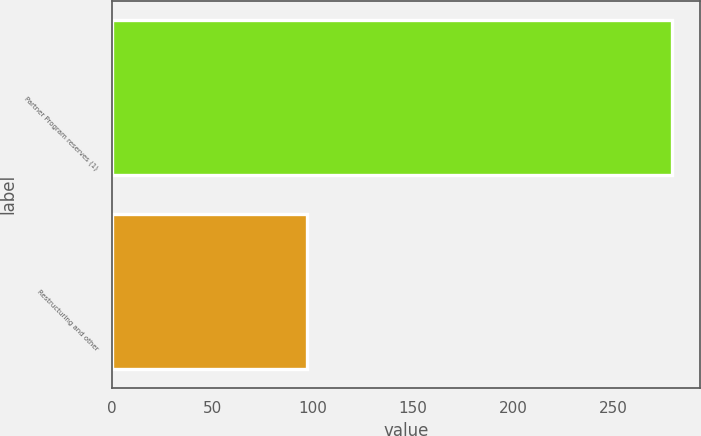Convert chart to OTSL. <chart><loc_0><loc_0><loc_500><loc_500><bar_chart><fcel>Partner Program reserves (1)<fcel>Restructuring and other<nl><fcel>279.5<fcel>97<nl></chart> 